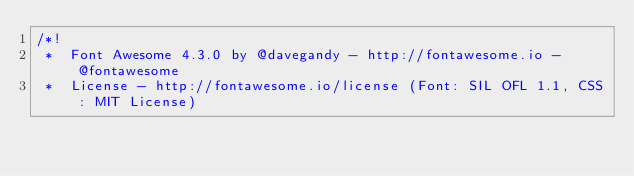<code> <loc_0><loc_0><loc_500><loc_500><_CSS_>/*!
 *  Font Awesome 4.3.0 by @davegandy - http://fontawesome.io - @fontawesome
 *  License - http://fontawesome.io/license (Font: SIL OFL 1.1, CSS: MIT License)</code> 